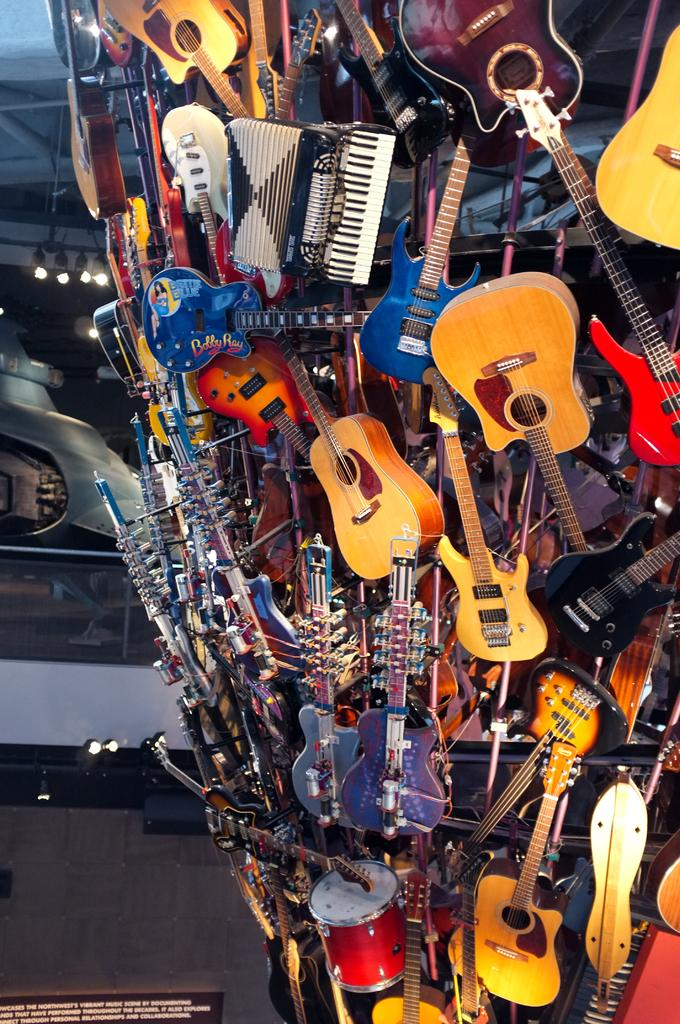What is the main subject of the image? The main subject of the image is many musical instruments. How are the musical instruments arranged or positioned in the image? The musical instruments are attached to an object. How many bridges can be seen in the image? There are no bridges present in the image. What type of pies are being played by the musical instruments in the image? There are no pies present in the image, and musical instruments do not play pies. 